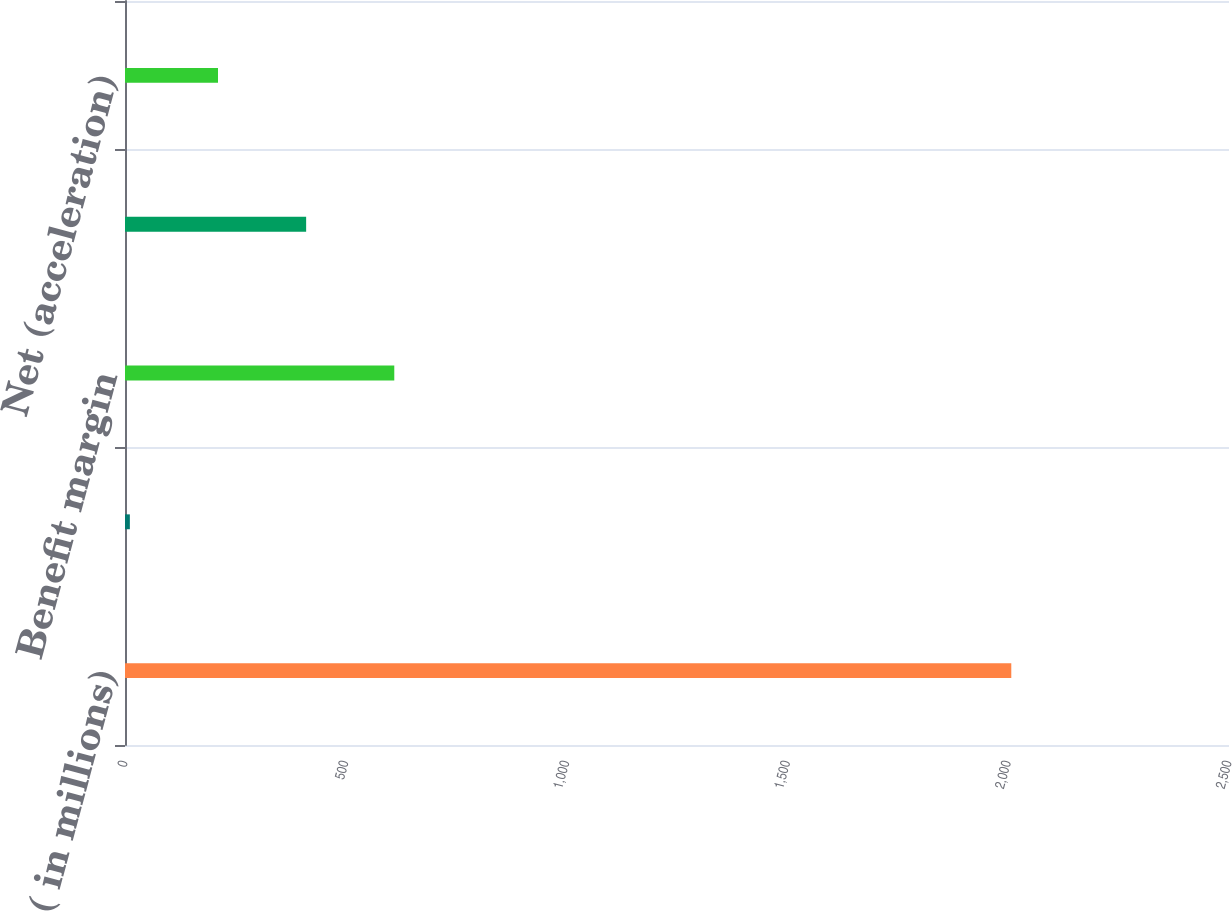Convert chart to OTSL. <chart><loc_0><loc_0><loc_500><loc_500><bar_chart><fcel>( in millions)<fcel>Investment margin<fcel>Benefit margin<fcel>Expense margin<fcel>Net (acceleration)<nl><fcel>2007<fcel>11<fcel>609.8<fcel>410.2<fcel>210.6<nl></chart> 